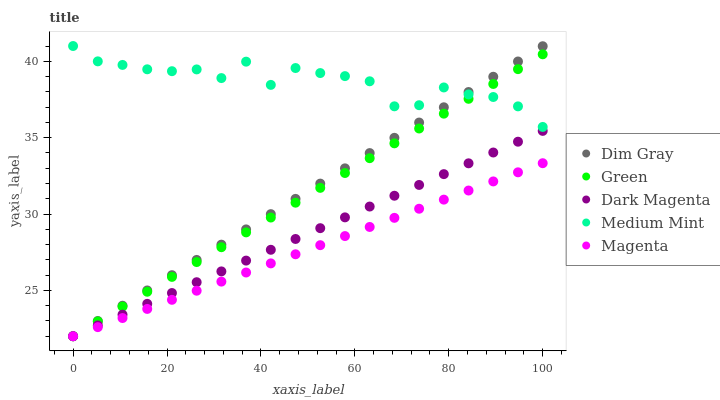Does Magenta have the minimum area under the curve?
Answer yes or no. Yes. Does Medium Mint have the maximum area under the curve?
Answer yes or no. Yes. Does Dim Gray have the minimum area under the curve?
Answer yes or no. No. Does Dim Gray have the maximum area under the curve?
Answer yes or no. No. Is Magenta the smoothest?
Answer yes or no. Yes. Is Medium Mint the roughest?
Answer yes or no. Yes. Is Dim Gray the smoothest?
Answer yes or no. No. Is Dim Gray the roughest?
Answer yes or no. No. Does Magenta have the lowest value?
Answer yes or no. Yes. Does Medium Mint have the highest value?
Answer yes or no. Yes. Does Dim Gray have the highest value?
Answer yes or no. No. Is Dark Magenta less than Medium Mint?
Answer yes or no. Yes. Is Medium Mint greater than Magenta?
Answer yes or no. Yes. Does Medium Mint intersect Dim Gray?
Answer yes or no. Yes. Is Medium Mint less than Dim Gray?
Answer yes or no. No. Is Medium Mint greater than Dim Gray?
Answer yes or no. No. Does Dark Magenta intersect Medium Mint?
Answer yes or no. No. 